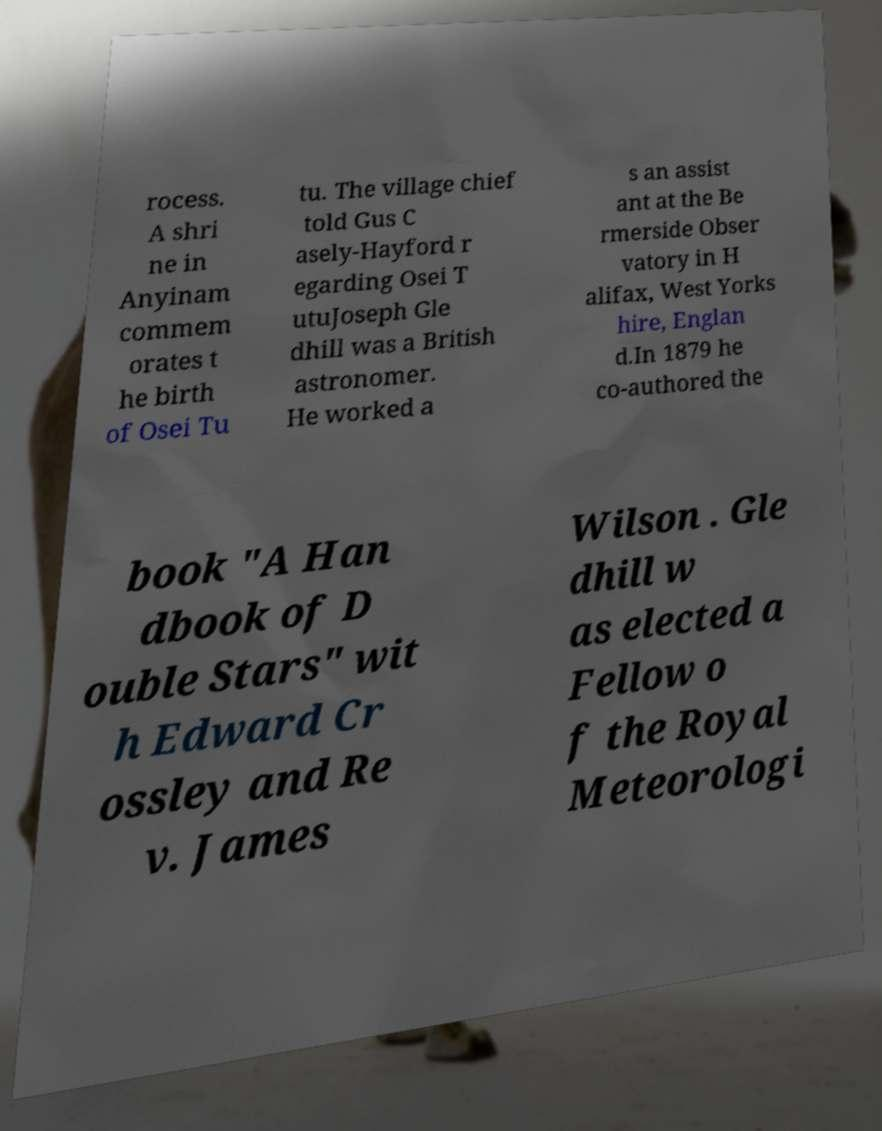Please read and relay the text visible in this image. What does it say? rocess. A shri ne in Anyinam commem orates t he birth of Osei Tu tu. The village chief told Gus C asely-Hayford r egarding Osei T utuJoseph Gle dhill was a British astronomer. He worked a s an assist ant at the Be rmerside Obser vatory in H alifax, West Yorks hire, Englan d.In 1879 he co-authored the book "A Han dbook of D ouble Stars" wit h Edward Cr ossley and Re v. James Wilson . Gle dhill w as elected a Fellow o f the Royal Meteorologi 